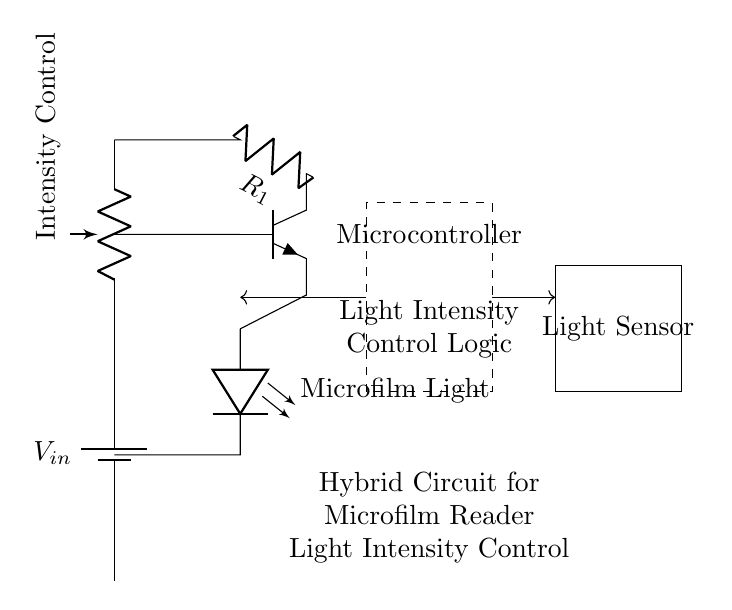What is the main function of the potentiometer in this circuit? The potentiometer is used for light intensity control, allowing users to adjust the brightness of the microfilm light.
Answer: Light intensity control What type of transistor is used in this circuit? The circuit uses an NPN transistor, which is indicated by the label npn on the diagram.
Answer: NPN How many main components are shown in the circuit? The circuit diagram shows five main components: a battery, a potentiometer, a transistor, a light-emitting diode (LED), and a microcontroller.
Answer: Five Which component generates light in this circuit? The light-emitting diode (LED) labeled as Microfilm Light generates light in this circuit, functioning as the illumination source for the microfilm.
Answer: Microfilm Light What is the purpose of the microcontroller in this circuit? The microcontroller manages light intensity control logic, receiving data from the light sensor and adjusting the LED brightness accordingly.
Answer: Control logic How does light intensity affect the operation of the transistor? The light intensity detected by the light sensor influences the microcontroller, which controls the base current of the transistor, ultimately adjusting the LED brightness based on the measured light levels.
Answer: Adjusts LED brightness 